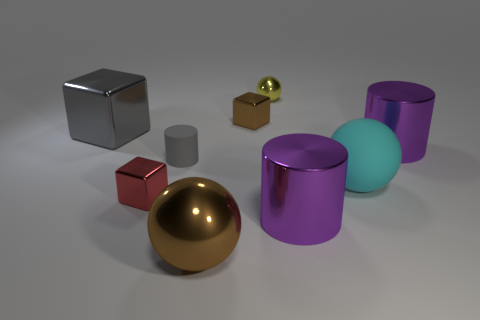Is the large brown sphere made of the same material as the large ball that is behind the brown ball?
Make the answer very short. No. What number of things are large purple cylinders or small red metal things?
Your response must be concise. 3. Are any large gray objects visible?
Give a very brief answer. Yes. What shape is the brown object in front of the gray thing in front of the gray shiny thing?
Provide a short and direct response. Sphere. What number of things are either tiny metal objects that are in front of the big gray metallic block or metal objects on the left side of the large cyan ball?
Your response must be concise. 6. There is a gray object that is the same size as the brown block; what material is it?
Make the answer very short. Rubber. The matte sphere is what color?
Offer a terse response. Cyan. What is the tiny thing that is left of the yellow metal object and behind the large gray block made of?
Provide a short and direct response. Metal. There is a big cylinder that is on the right side of the big sphere that is behind the big brown metallic sphere; is there a purple metal thing in front of it?
Keep it short and to the point. Yes. What is the size of the metal cube that is the same color as the small rubber object?
Offer a terse response. Large. 